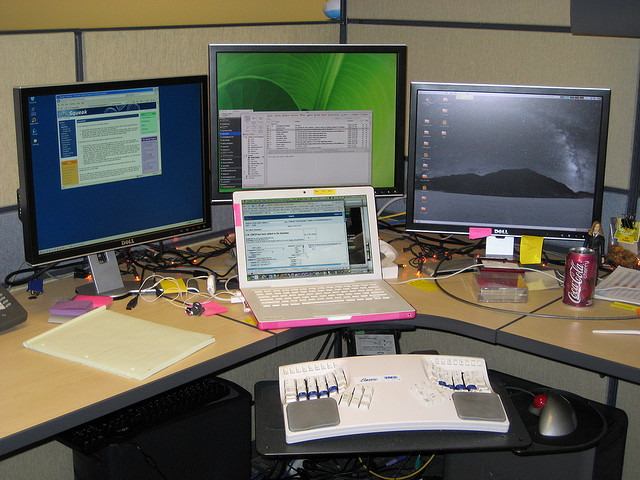<image>What toy is on top of the speaker? There is no toy on the speaker. It is unclear or the speaker is not visible in the image. What toy is on top of the speaker? I don't know what toy is on top of the speaker. It can be seen 'computers', 'laptop', 'bird', 'doll', or it can be nothing. 